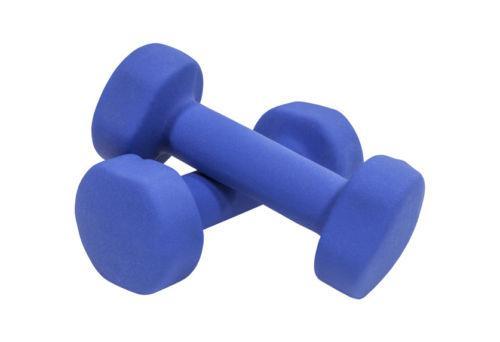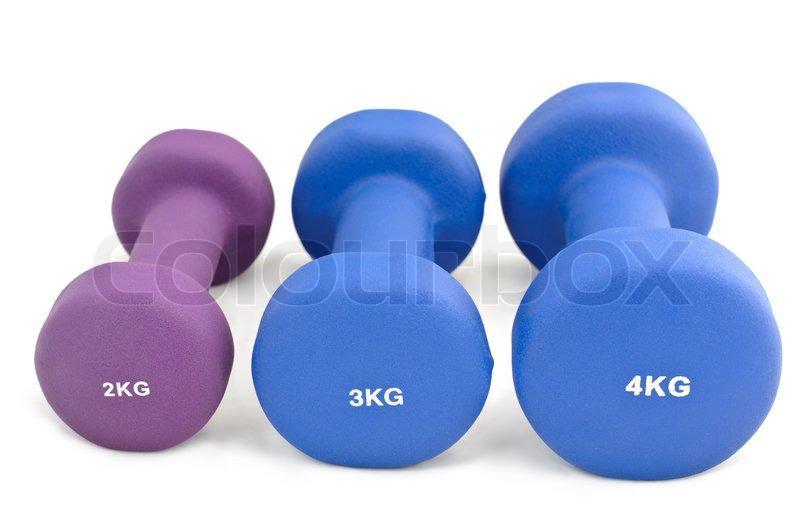The first image is the image on the left, the second image is the image on the right. For the images displayed, is the sentence "Two hand weights in each image are a matched set, dark colored weights with six sides that are attached to a metal bar." factually correct? Answer yes or no. No. The first image is the image on the left, the second image is the image on the right. Given the left and right images, does the statement "The right image contains two dumbbells with black ends and a chrome middle bar." hold true? Answer yes or no. No. 